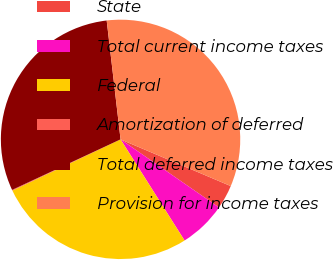<chart> <loc_0><loc_0><loc_500><loc_500><pie_chart><fcel>State<fcel>Total current income taxes<fcel>Federal<fcel>Amortization of deferred<fcel>Total deferred income taxes<fcel>Provision for income taxes<nl><fcel>3.25%<fcel>6.39%<fcel>26.94%<fcel>0.1%<fcel>30.09%<fcel>33.23%<nl></chart> 